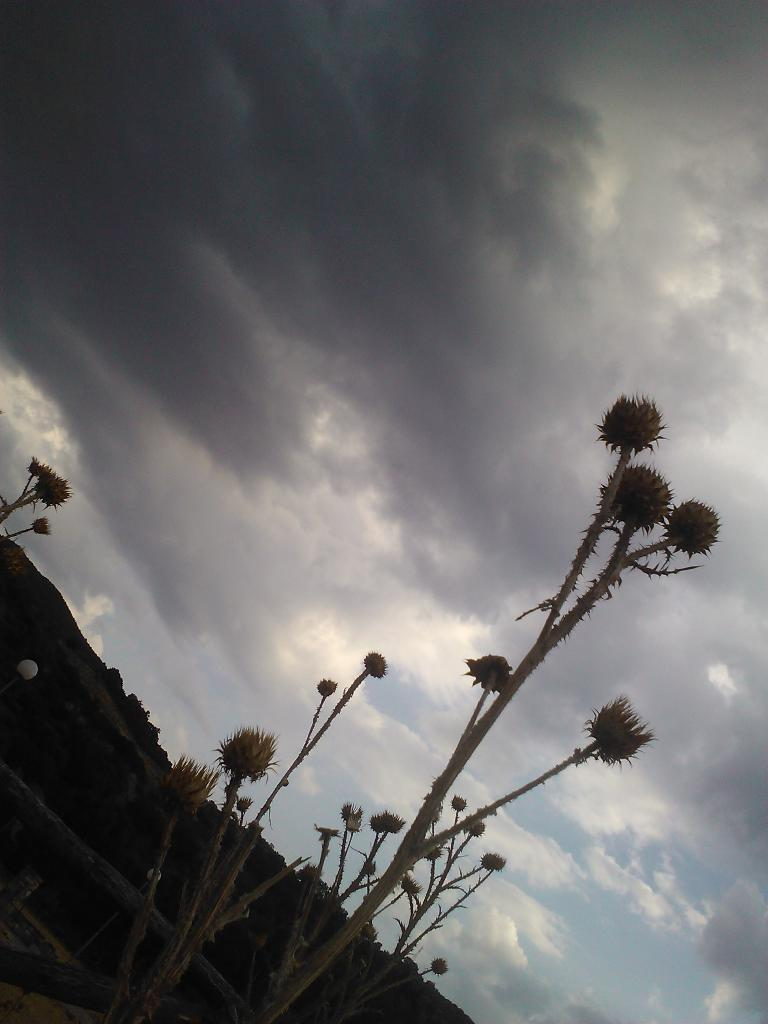What type of plants are visible at the bottom of the image? There are plants with fruits at the bottom of the image. What can be seen in the distance in the background of the image? There is a mountain in the background of the image. What is visible in the sky in the background of the image? There are clouds in the sky in the background of the image. What type of profit can be seen on the floor in the image? There is no profit or floor present in the image; it features plants with fruits and a mountain in the background. 